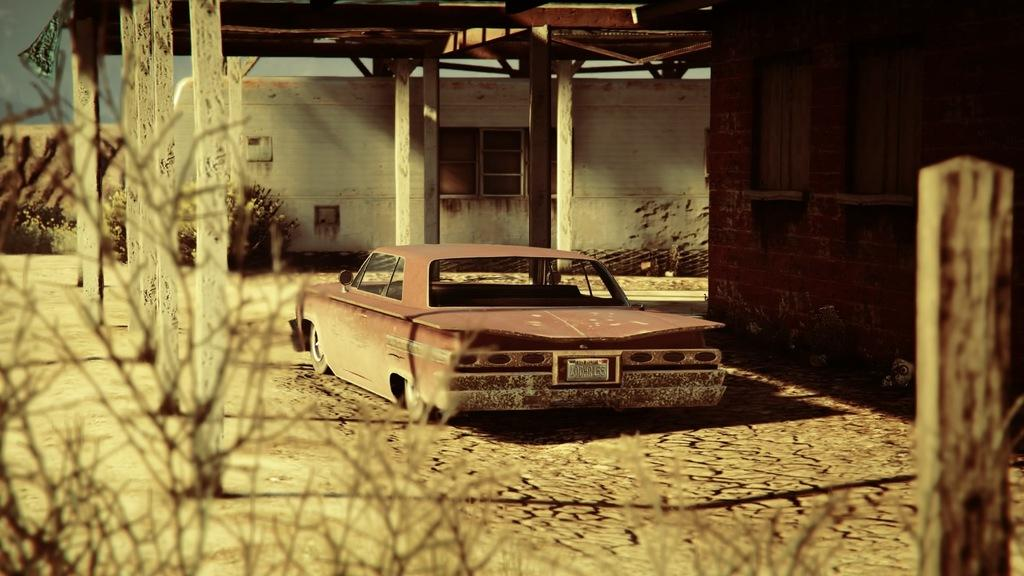What is the main subject of the image? There is a car in the image. Where is the car located? The car is under a wooden roof. What other structures are present in the image? There are wooden poles in the image. What type of vegetation can be seen in the image? There are plants in the image. What is the background of the image? There is a wall in the image, and the sky is visible. Are there any natural elements in the image? Yes, there are branches of a tree in the image. What type of vegetable is growing on the car in the image? There are no vegetables growing on the car in the image. Can you tell me how many squirrels are sitting on the branches of the tree in the image? There are no squirrels present in the image. 